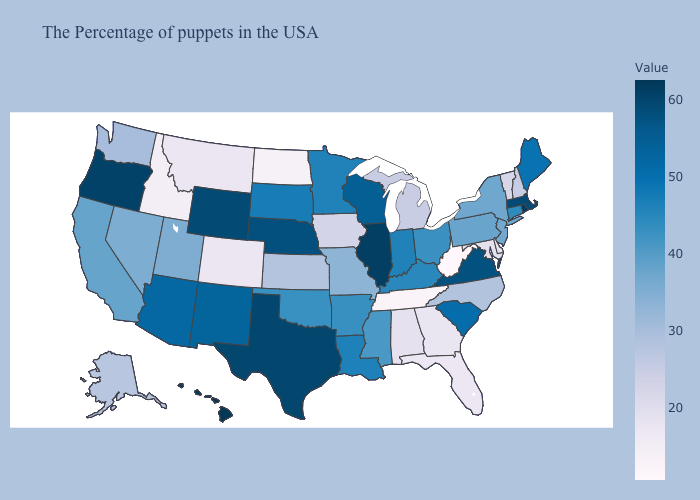Which states hav the highest value in the West?
Concise answer only. Hawaii. Is the legend a continuous bar?
Write a very short answer. Yes. Does Hawaii have the highest value in the USA?
Answer briefly. Yes. Does Georgia have a lower value than Nebraska?
Be succinct. Yes. Does Massachusetts have a lower value than Delaware?
Quick response, please. No. Does Maryland have a lower value than North Dakota?
Be succinct. No. Is the legend a continuous bar?
Give a very brief answer. Yes. 